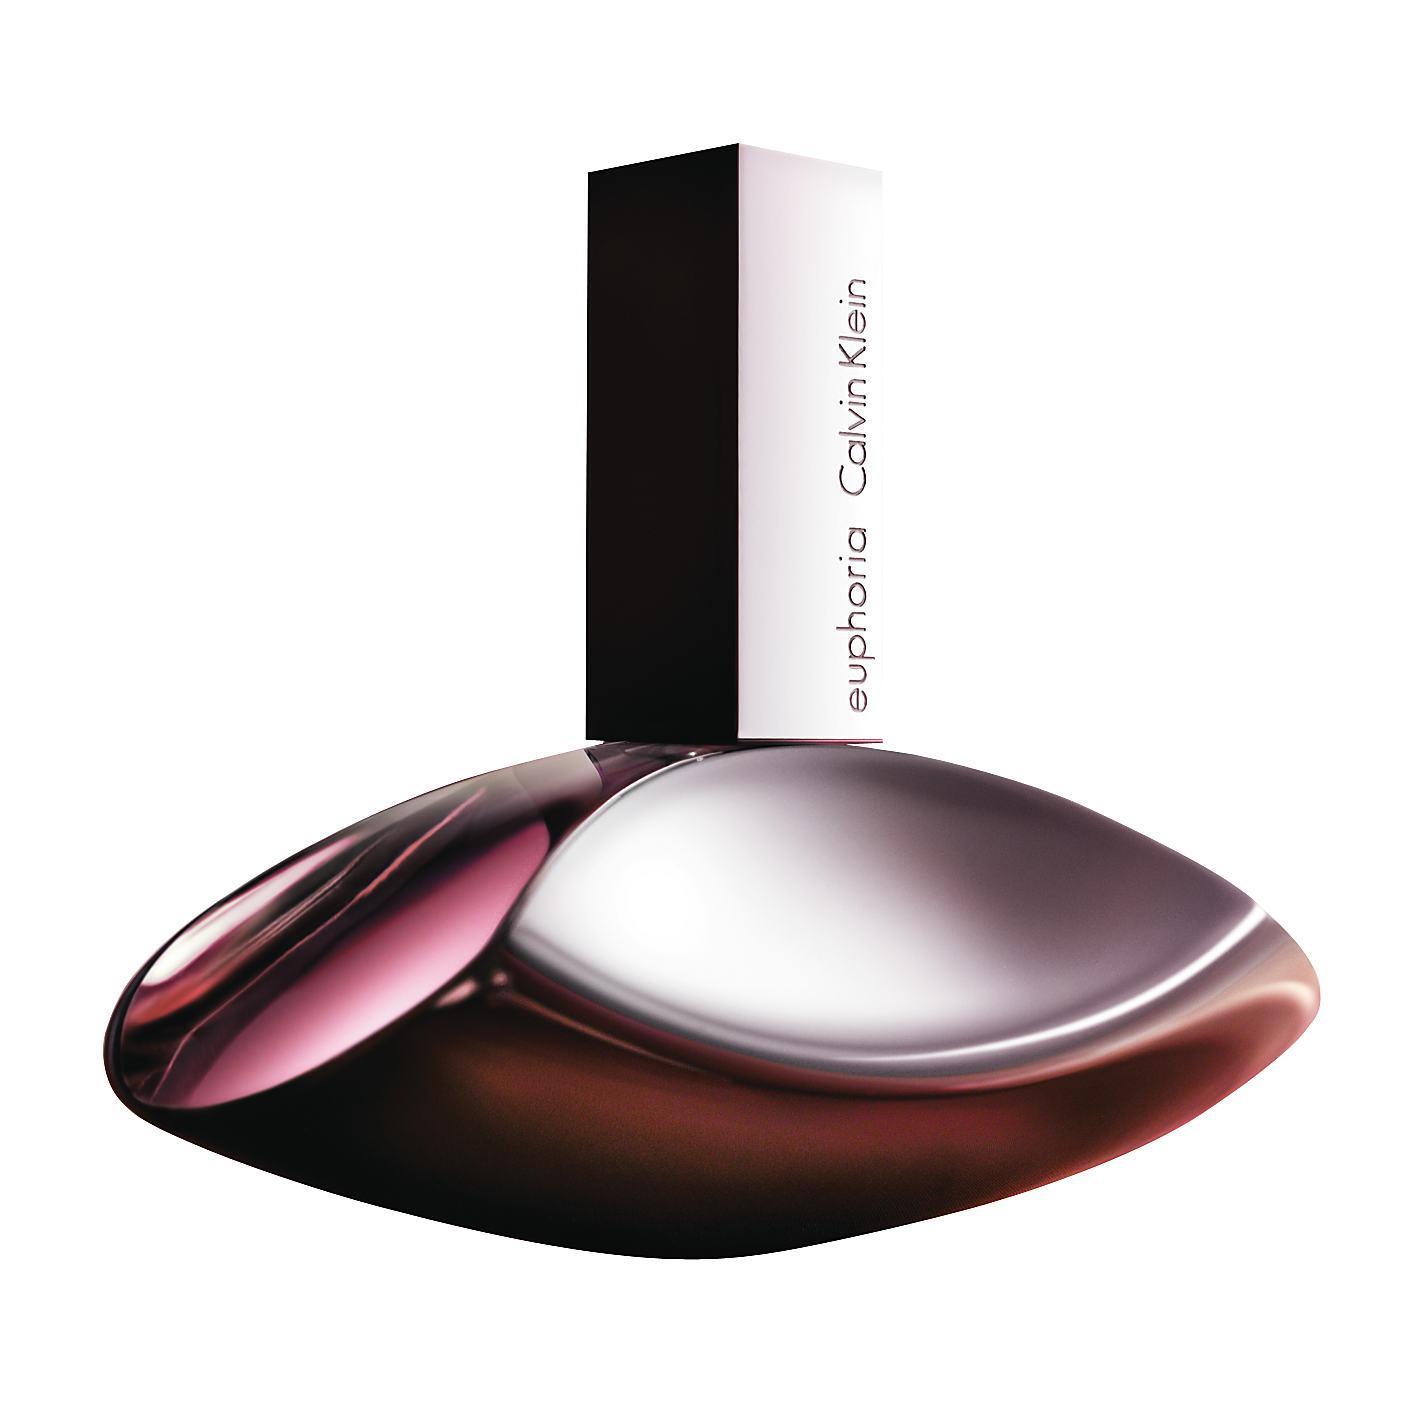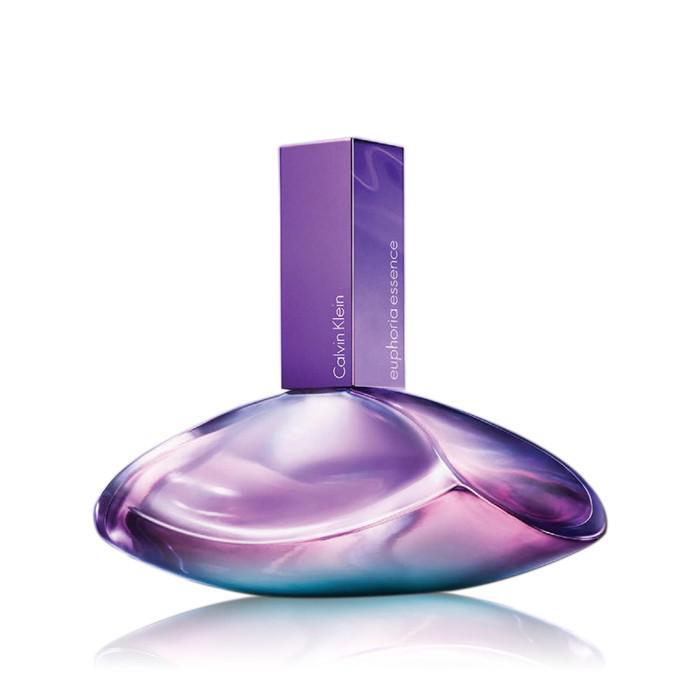The first image is the image on the left, the second image is the image on the right. Analyze the images presented: Is the assertion "There is a box beside the bottle in one of the images." valid? Answer yes or no. No. 